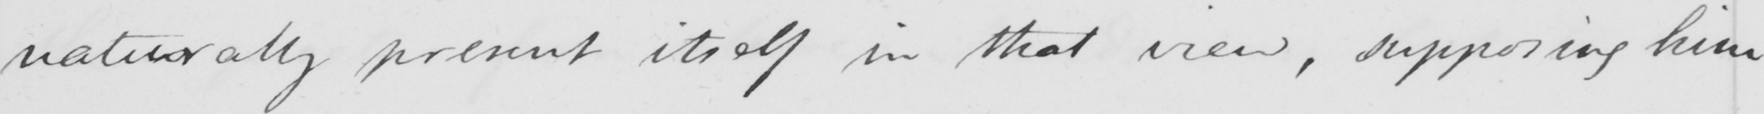Please transcribe the handwritten text in this image. naturally present itself in that view , supposing him 